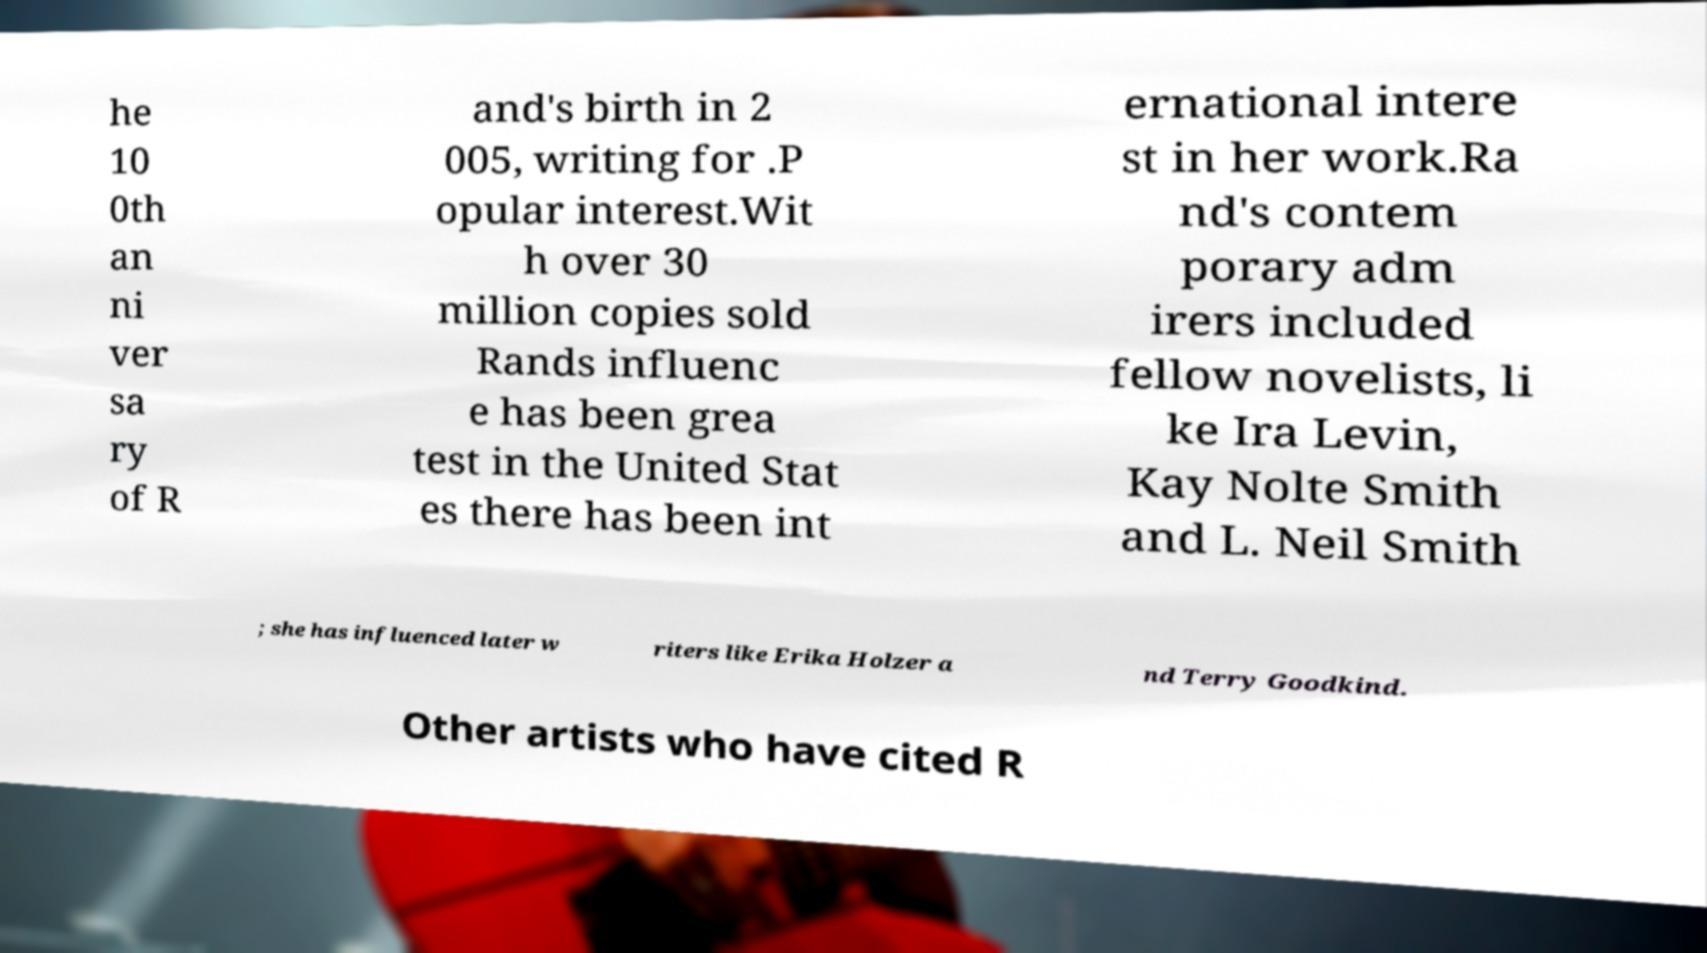There's text embedded in this image that I need extracted. Can you transcribe it verbatim? he 10 0th an ni ver sa ry of R and's birth in 2 005, writing for .P opular interest.Wit h over 30 million copies sold Rands influenc e has been grea test in the United Stat es there has been int ernational intere st in her work.Ra nd's contem porary adm irers included fellow novelists, li ke Ira Levin, Kay Nolte Smith and L. Neil Smith ; she has influenced later w riters like Erika Holzer a nd Terry Goodkind. Other artists who have cited R 